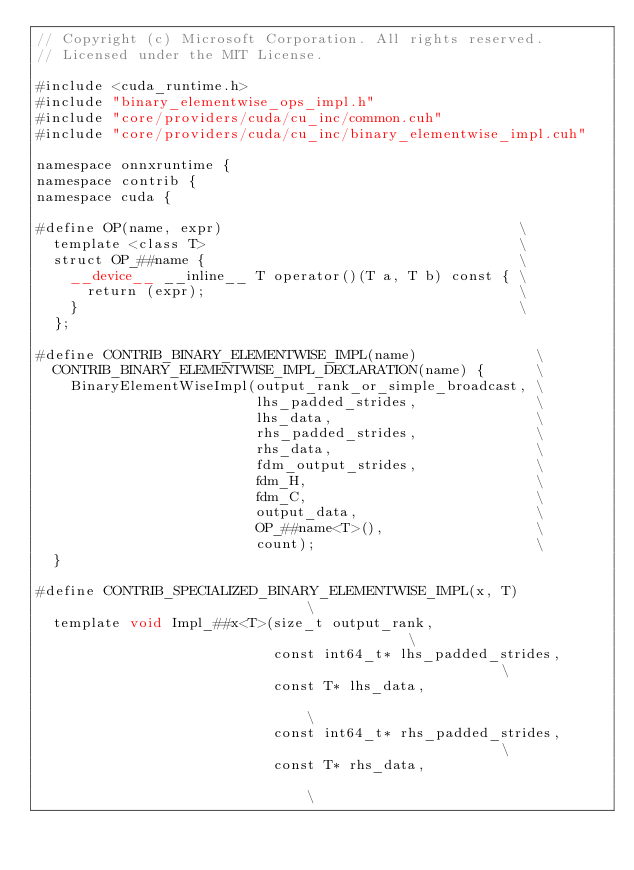Convert code to text. <code><loc_0><loc_0><loc_500><loc_500><_Cuda_>// Copyright (c) Microsoft Corporation. All rights reserved.
// Licensed under the MIT License.

#include <cuda_runtime.h>
#include "binary_elementwise_ops_impl.h"
#include "core/providers/cuda/cu_inc/common.cuh"
#include "core/providers/cuda/cu_inc/binary_elementwise_impl.cuh"

namespace onnxruntime {
namespace contrib {
namespace cuda {

#define OP(name, expr)                                   \
  template <class T>                                     \
  struct OP_##name {                                     \
    __device__ __inline__ T operator()(T a, T b) const { \
      return (expr);                                     \
    }                                                    \
  };

#define CONTRIB_BINARY_ELEMENTWISE_IMPL(name)              \
  CONTRIB_BINARY_ELEMENTWISE_IMPL_DECLARATION(name) {      \
    BinaryElementWiseImpl(output_rank_or_simple_broadcast, \
                          lhs_padded_strides,              \
                          lhs_data,                        \
                          rhs_padded_strides,              \
                          rhs_data,                        \
                          fdm_output_strides,              \
                          fdm_H,                           \
                          fdm_C,                           \
                          output_data,                     \
                          OP_##name<T>(),                  \
                          count);                          \
  }

#define CONTRIB_SPECIALIZED_BINARY_ELEMENTWISE_IMPL(x, T)                             \
  template void Impl_##x<T>(size_t output_rank,                                       \
                            const int64_t* lhs_padded_strides,                        \
                            const T* lhs_data,                                        \
                            const int64_t* rhs_padded_strides,                        \
                            const T* rhs_data,                                        \</code> 